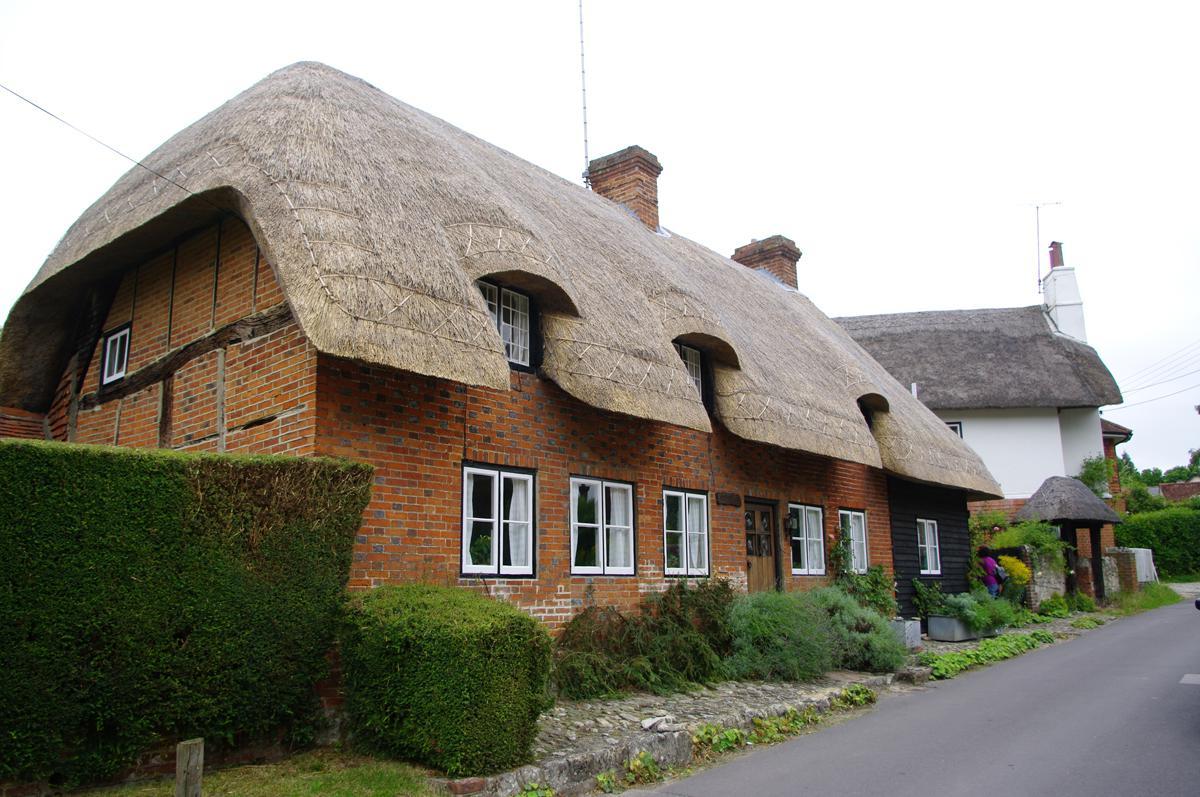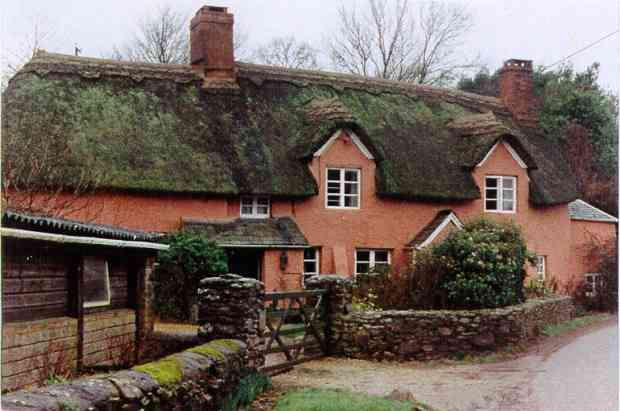The first image is the image on the left, the second image is the image on the right. For the images shown, is this caption "A building with a shaggy thatched roof topped with a notched border has two projecting dormer windows and stone columns at the entrance to the property." true? Answer yes or no. Yes. The first image is the image on the left, the second image is the image on the right. Given the left and right images, does the statement "A fence runs around the house in the image on the right." hold true? Answer yes or no. Yes. 